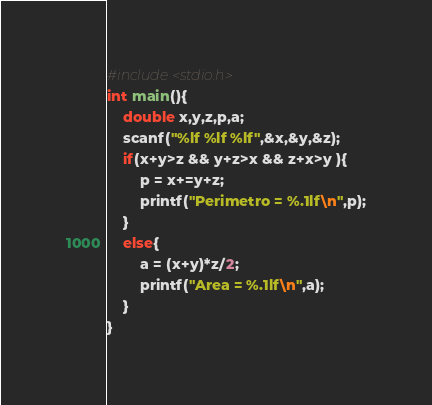<code> <loc_0><loc_0><loc_500><loc_500><_C_>#include<stdio.h>
int main(){
    double x,y,z,p,a;
    scanf("%lf %lf %lf",&x,&y,&z);
    if(x+y>z && y+z>x && z+x>y ){
        p = x+=y+z;
        printf("Perimetro = %.1lf\n",p);
    }
    else{
        a = (x+y)*z/2;
        printf("Area = %.1lf\n",a);
    }
}
</code> 